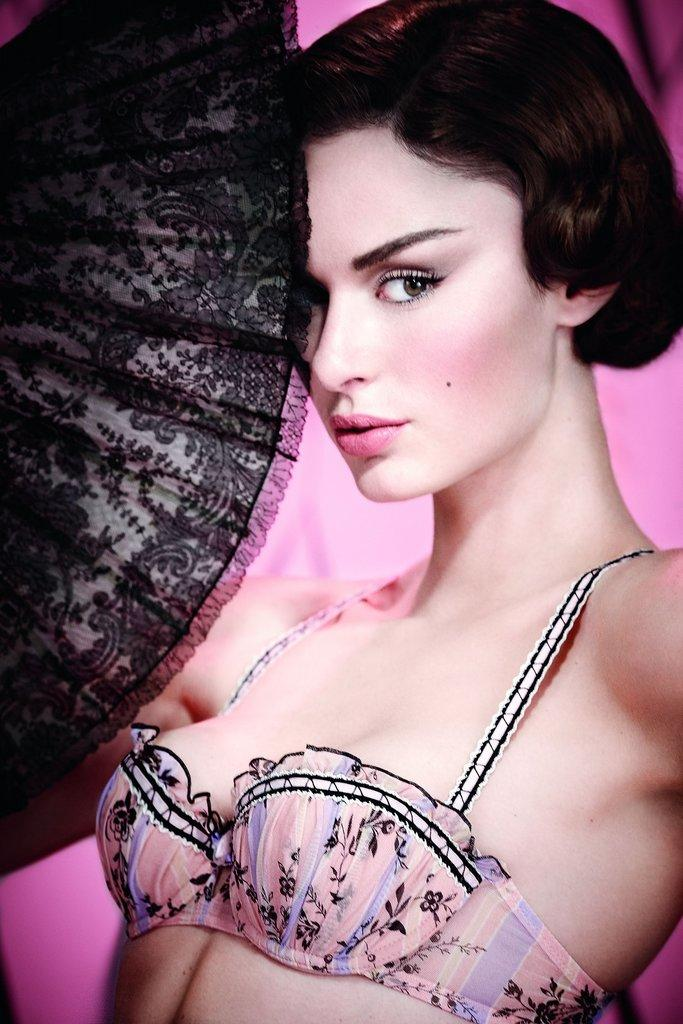Who is present in the image? There is a woman in the image. What is the woman wearing? The woman is wearing a fashion dress. What color is the dress? The dress is pink in color. What type of dock can be seen in the background of the image? There is no dock present in the image; it only features a woman wearing a pink fashion dress. What kind of canvas is being used to create the artwork in the image? There is no artwork or canvas present in the image; it only features a woman wearing a pink fashion dress. 